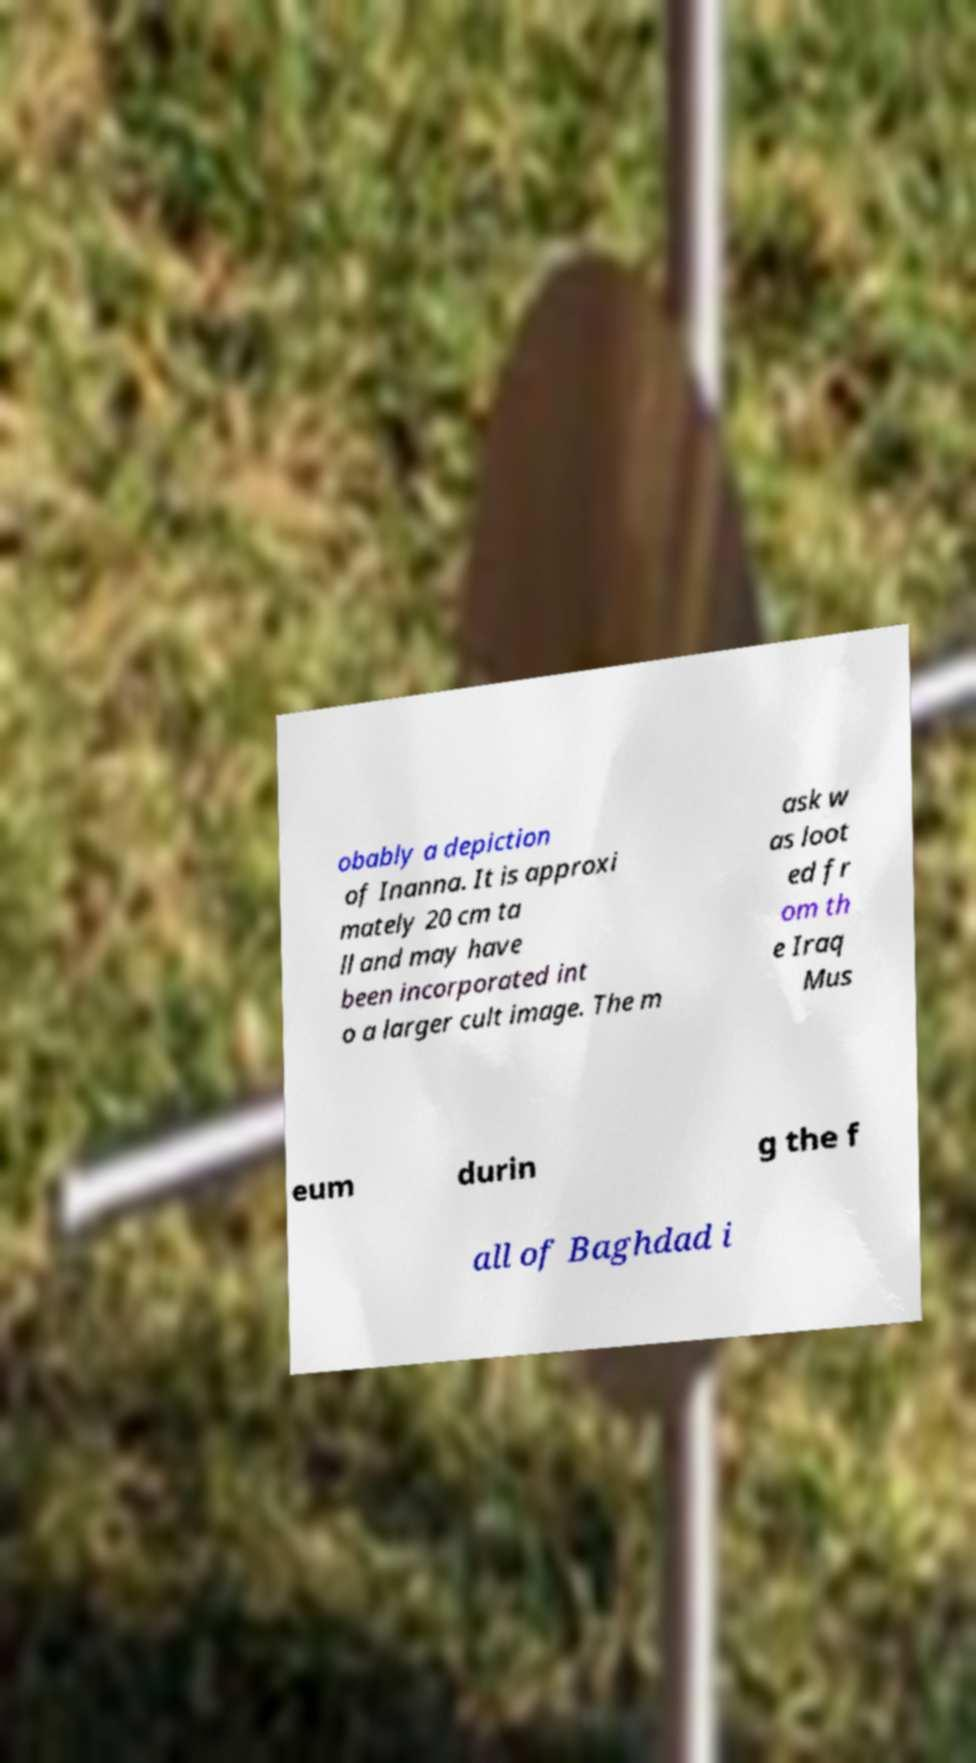Could you extract and type out the text from this image? obably a depiction of Inanna. It is approxi mately 20 cm ta ll and may have been incorporated int o a larger cult image. The m ask w as loot ed fr om th e Iraq Mus eum durin g the f all of Baghdad i 